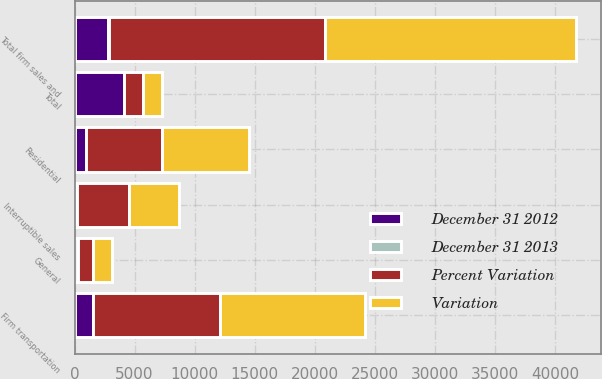<chart> <loc_0><loc_0><loc_500><loc_500><stacked_bar_chart><ecel><fcel>Residential<fcel>General<fcel>Firm transportation<fcel>Total firm sales and<fcel>Interruptible sales<fcel>Total<nl><fcel>Variation<fcel>7253<fcel>1555<fcel>12062<fcel>20870<fcel>4118<fcel>1556<nl><fcel>Percent Variation<fcel>6291<fcel>1248<fcel>10505<fcel>18044<fcel>4326<fcel>1556<nl><fcel>December 31 2012<fcel>962<fcel>307<fcel>1557<fcel>2826<fcel>208<fcel>4139<nl><fcel>December 31 2013<fcel>15.3<fcel>24.6<fcel>14.8<fcel>15.7<fcel>4.8<fcel>17.3<nl></chart> 